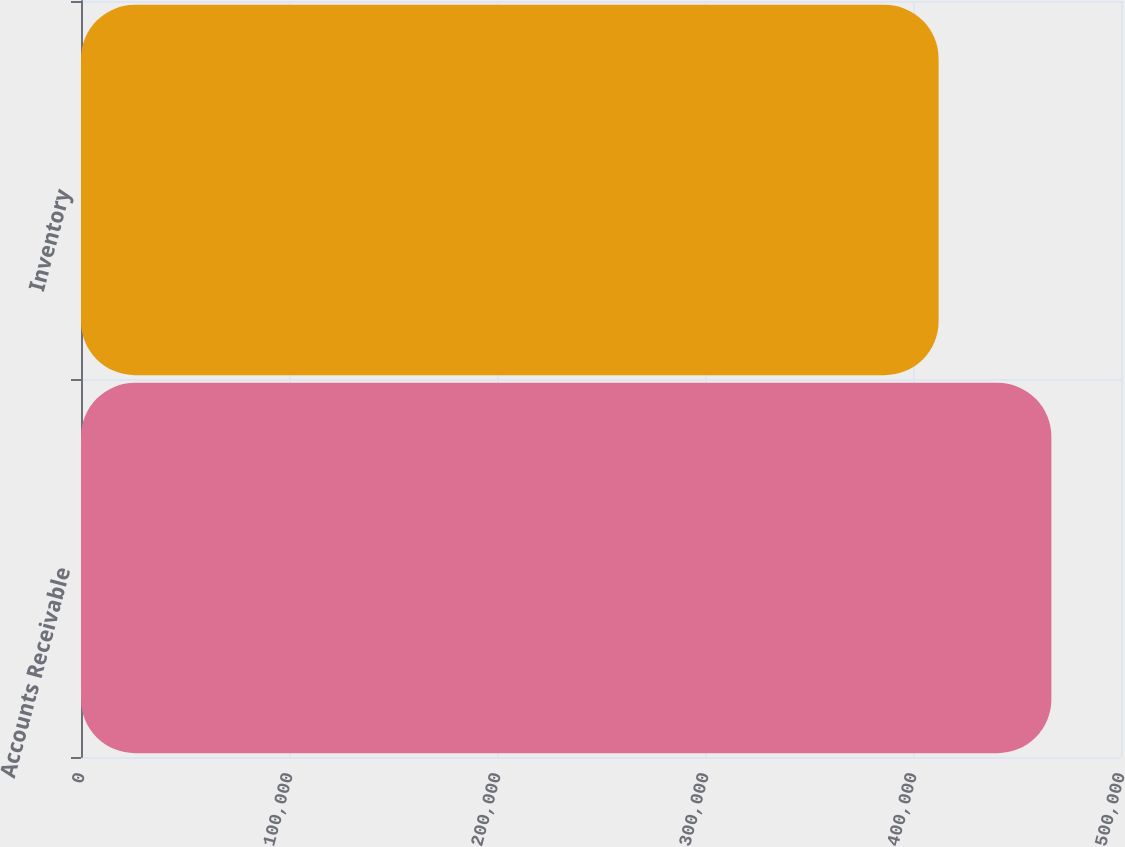<chart> <loc_0><loc_0><loc_500><loc_500><bar_chart><fcel>Accounts Receivable<fcel>Inventory<nl><fcel>466527<fcel>412314<nl></chart> 